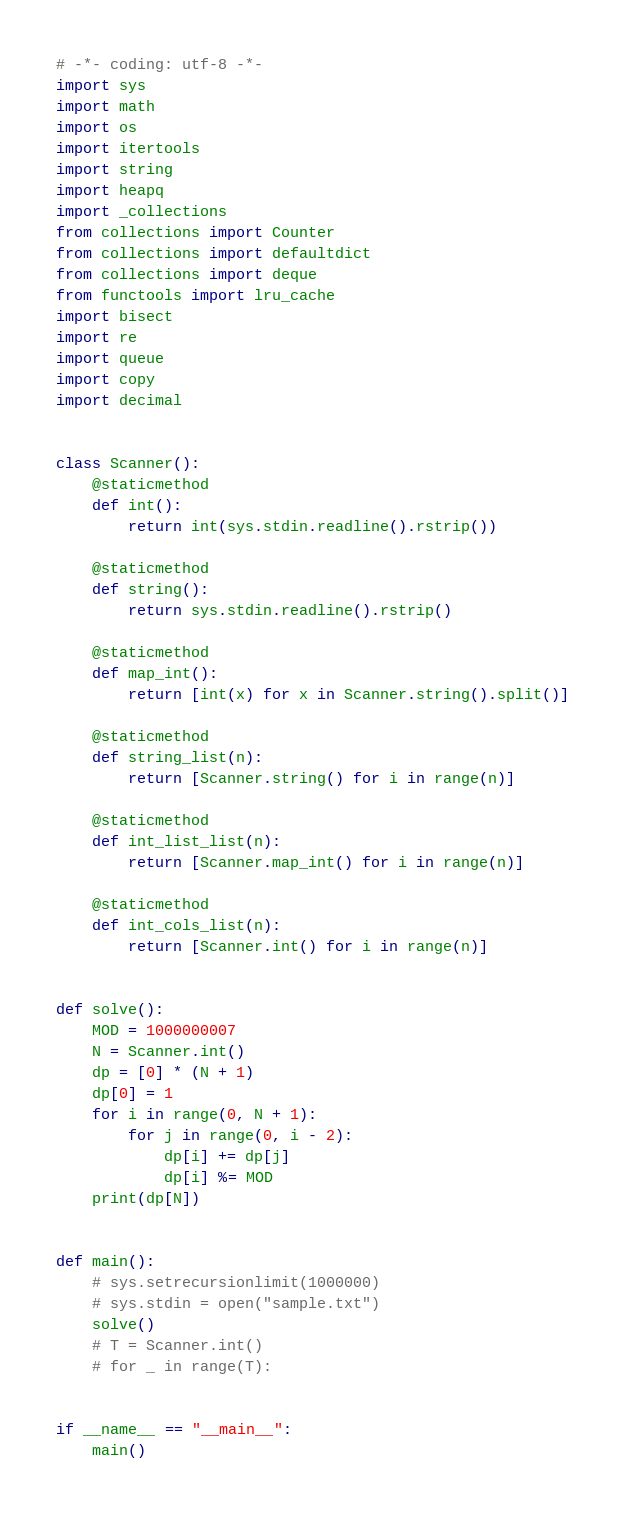<code> <loc_0><loc_0><loc_500><loc_500><_Python_># -*- coding: utf-8 -*-
import sys
import math
import os
import itertools
import string
import heapq
import _collections
from collections import Counter
from collections import defaultdict
from collections import deque
from functools import lru_cache
import bisect
import re
import queue
import copy
import decimal


class Scanner():
    @staticmethod
    def int():
        return int(sys.stdin.readline().rstrip())

    @staticmethod
    def string():
        return sys.stdin.readline().rstrip()

    @staticmethod
    def map_int():
        return [int(x) for x in Scanner.string().split()]

    @staticmethod
    def string_list(n):
        return [Scanner.string() for i in range(n)]

    @staticmethod
    def int_list_list(n):
        return [Scanner.map_int() for i in range(n)]

    @staticmethod
    def int_cols_list(n):
        return [Scanner.int() for i in range(n)]


def solve():
    MOD = 1000000007
    N = Scanner.int()
    dp = [0] * (N + 1)
    dp[0] = 1
    for i in range(0, N + 1):
        for j in range(0, i - 2):
            dp[i] += dp[j]
            dp[i] %= MOD
    print(dp[N])


def main():
    # sys.setrecursionlimit(1000000)
    # sys.stdin = open("sample.txt")
    solve()
    # T = Scanner.int()
    # for _ in range(T):


if __name__ == "__main__":
    main()
</code> 